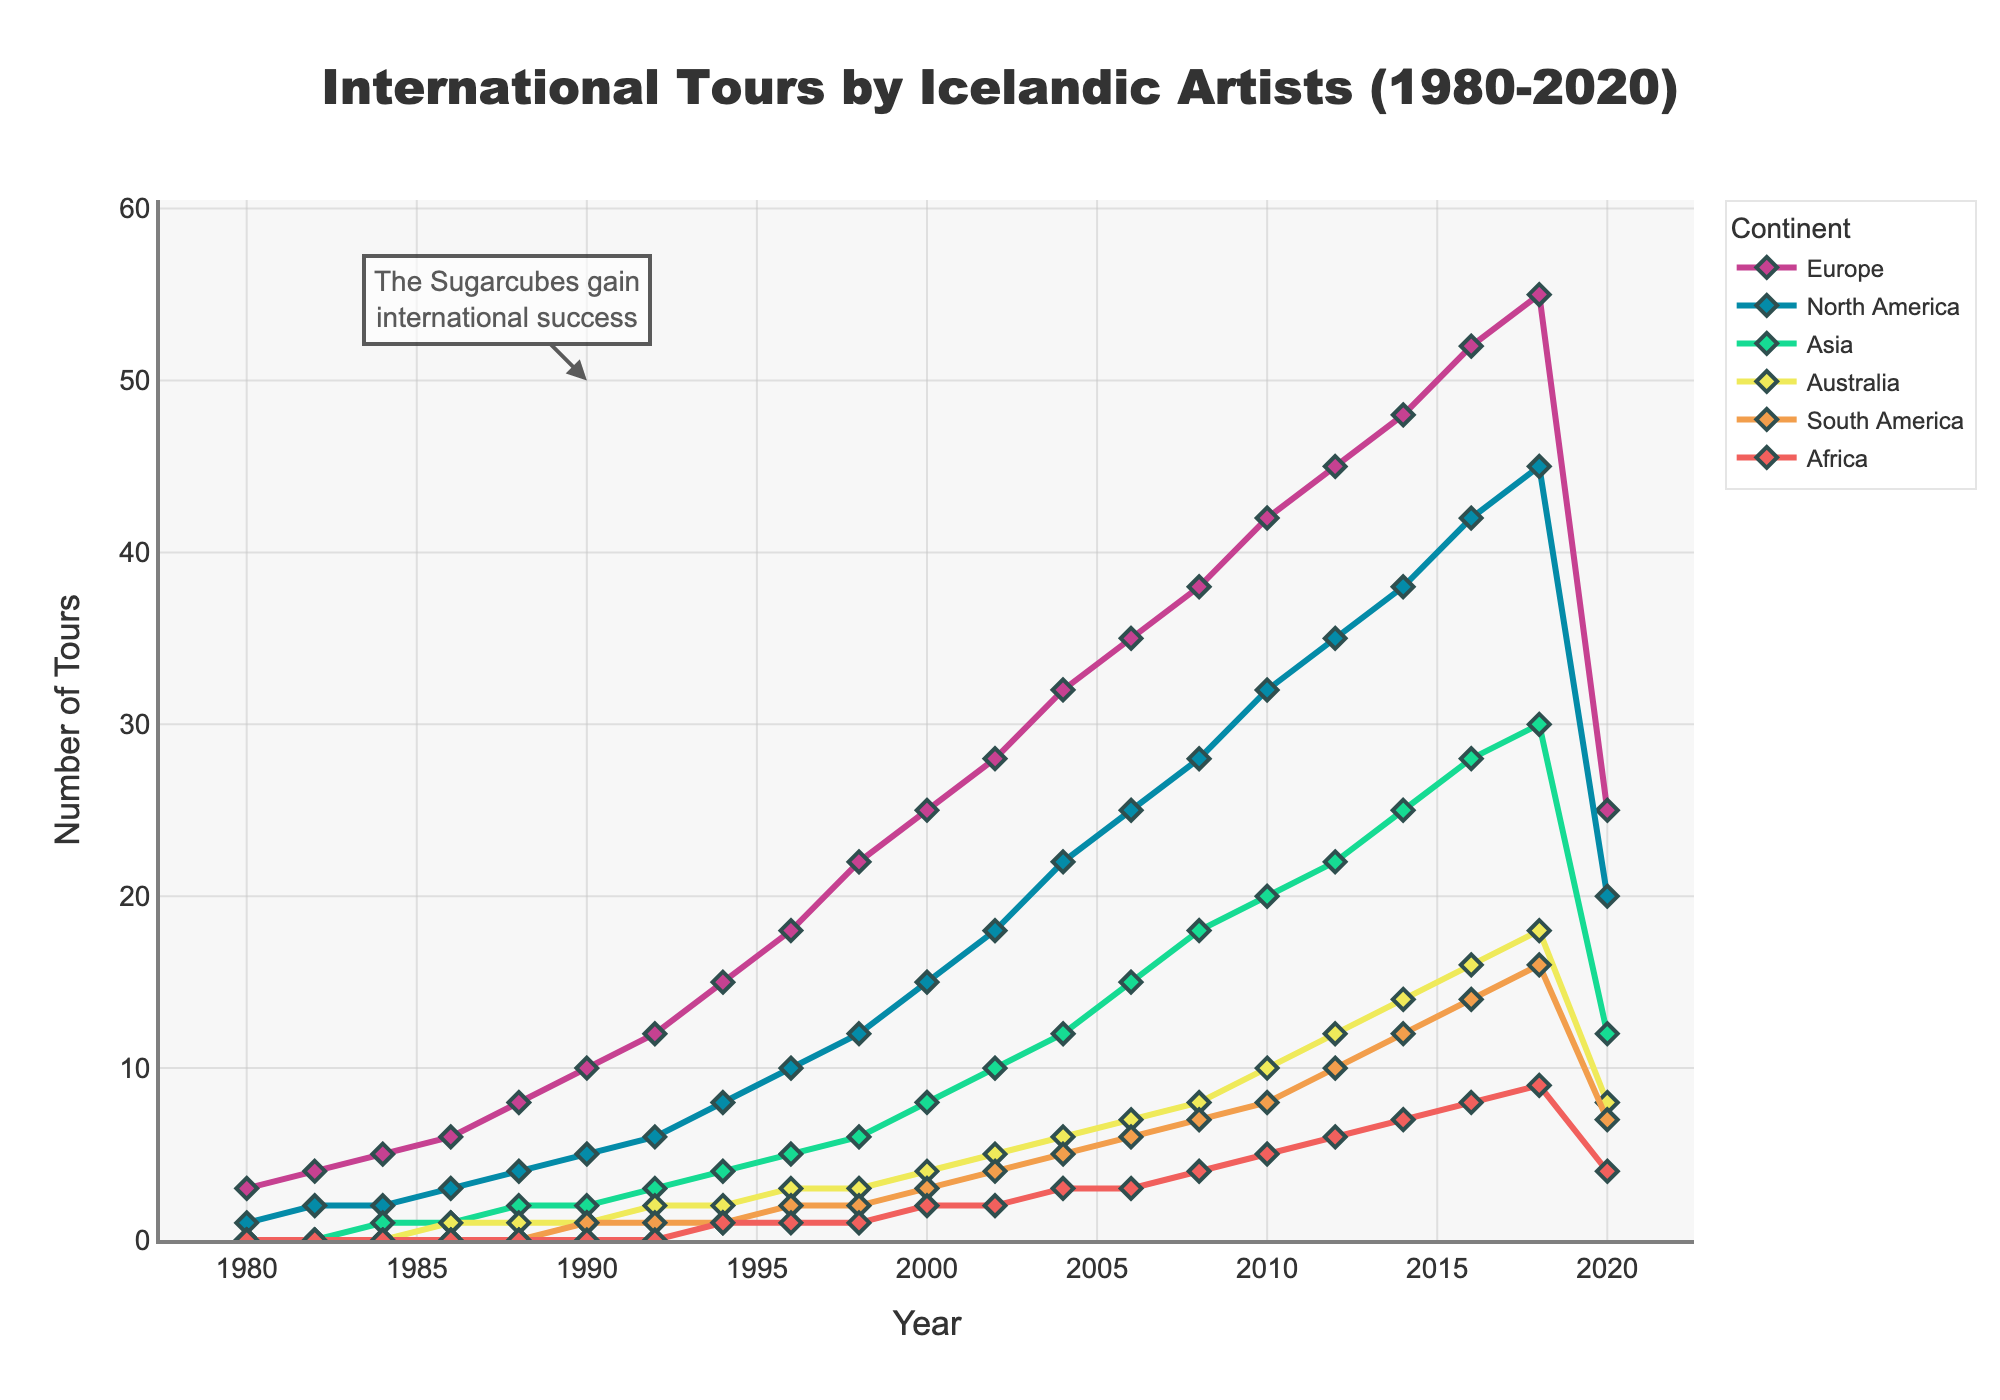What is the overall trend in the number of tours to Europe from 1980 to 2020? Observing the line representing Europe, it shows a steady increase in the number of tours from 1980 up to 2018. However, there is a sudden drop in the number of tours in 2020.
Answer: Steady increase, then a drop in 2020 How many tours were made to North America in 2000 compared to 2018? In 2000, the number of tours to North America was 15. In 2018, it increased to 45. Subtracting the former from the latter (45 - 15) gives the difference.
Answer: 30 more tours in 2018 Which continent reached a peak in the number of tours in 2018 before a significant drop in 2020? The line representing Europe peaks in 2018 with 55 tours, before significantly dropping to 25 in 2020.
Answer: Europe What is the combined number of tours to Asia in 2004 and 2008? In 2004, the number of tours to Asia was 12, and in 2008, it was 18. Adding these together (12 + 18), we get the total combined number.
Answer: 30 tours Which continent has the fewest tours overall and how many tours did it have at its peak year? Observing the lines, Africa consistently has the fewest tours overall compared to other continents. At its peak, Africa had 9 tours, which occurred in 2018.
Answer: Africa, 9 tours Which years saw the same number of tours to South America? According to the chart, South America had 2 tours consistently in 1996 and 1998, and again 7 tours in 2008 and 2020.
Answer: 1996, 1998 and 2008, 2020 How did tours to Australia change from 2006 to 2012? In 2006, there were 7 tours to Australia. By 2012, this number increased to 12 tours. Therefore, the change is an increase from 7 to 12.
Answer: Increase by 5 tours Which continent had the most significant increase in tours between 1992 and 2002? Between 1992 and 2002, Europe saw an increase from 12 to 28 tours. This is an increase of 16 tours, the largest among all continents.
Answer: Europe What annotation is attached to the graph, and which year does it relate to? The annotation points out "The Sugarcubes gain international success" and is linked to the year 1990.
Answer: The Sugarcubes' success, 1990 What is the average number of tours to North America in the entire dataset? Add the number of tours to North America for each year and divide by the total number of years: (1 + 2 + 2 + 3 + 4 + 5 + 6 + 8 + 10 + 12 + 15 + 18 + 22 + 25 + 28 + 32 + 35 + 38 + 42 + 45 + 20) / 21 years = 16.1
Answer: 16.1 